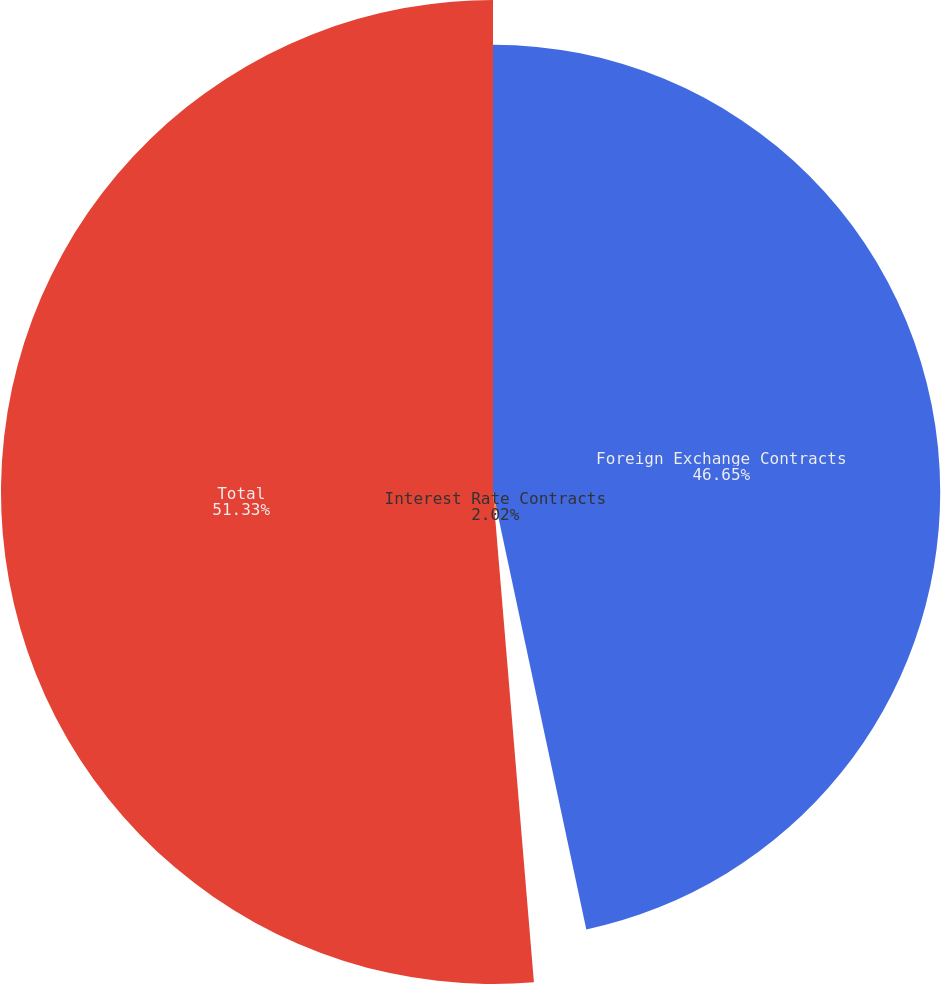<chart> <loc_0><loc_0><loc_500><loc_500><pie_chart><fcel>Foreign Exchange Contracts<fcel>Interest Rate Contracts<fcel>Total<nl><fcel>46.65%<fcel>2.02%<fcel>51.32%<nl></chart> 